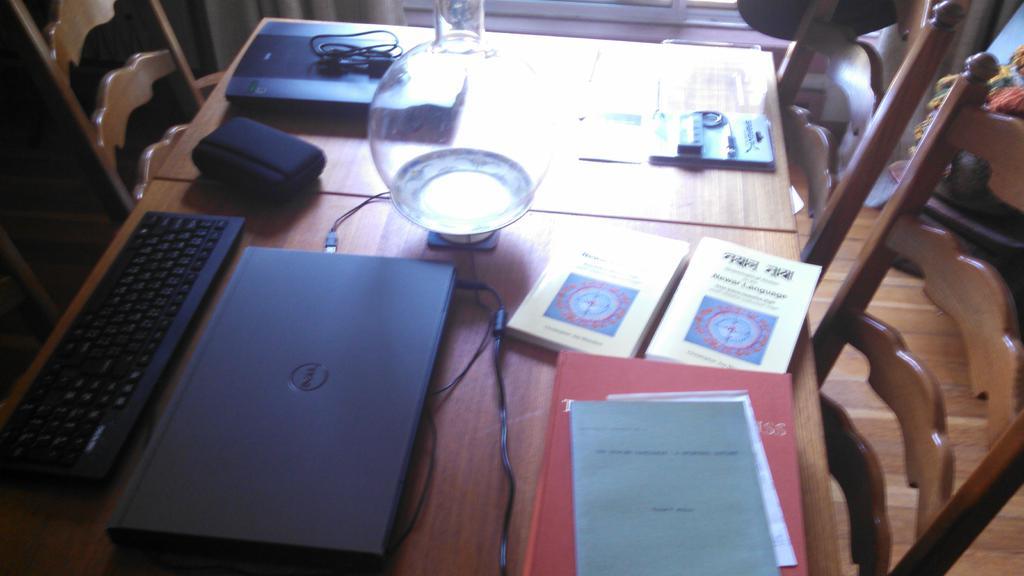In one or two sentences, can you explain what this image depicts? In this image I can see books,laptop,keyboard,glass on the table and there are also some chairs. 